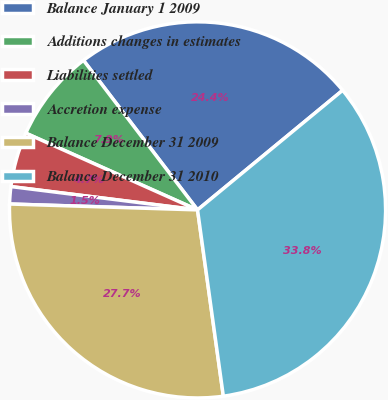Convert chart. <chart><loc_0><loc_0><loc_500><loc_500><pie_chart><fcel>Balance January 1 2009<fcel>Additions changes in estimates<fcel>Liabilities settled<fcel>Accretion expense<fcel>Balance December 31 2009<fcel>Balance December 31 2010<nl><fcel>24.4%<fcel>7.94%<fcel>4.71%<fcel>1.48%<fcel>27.69%<fcel>33.78%<nl></chart> 